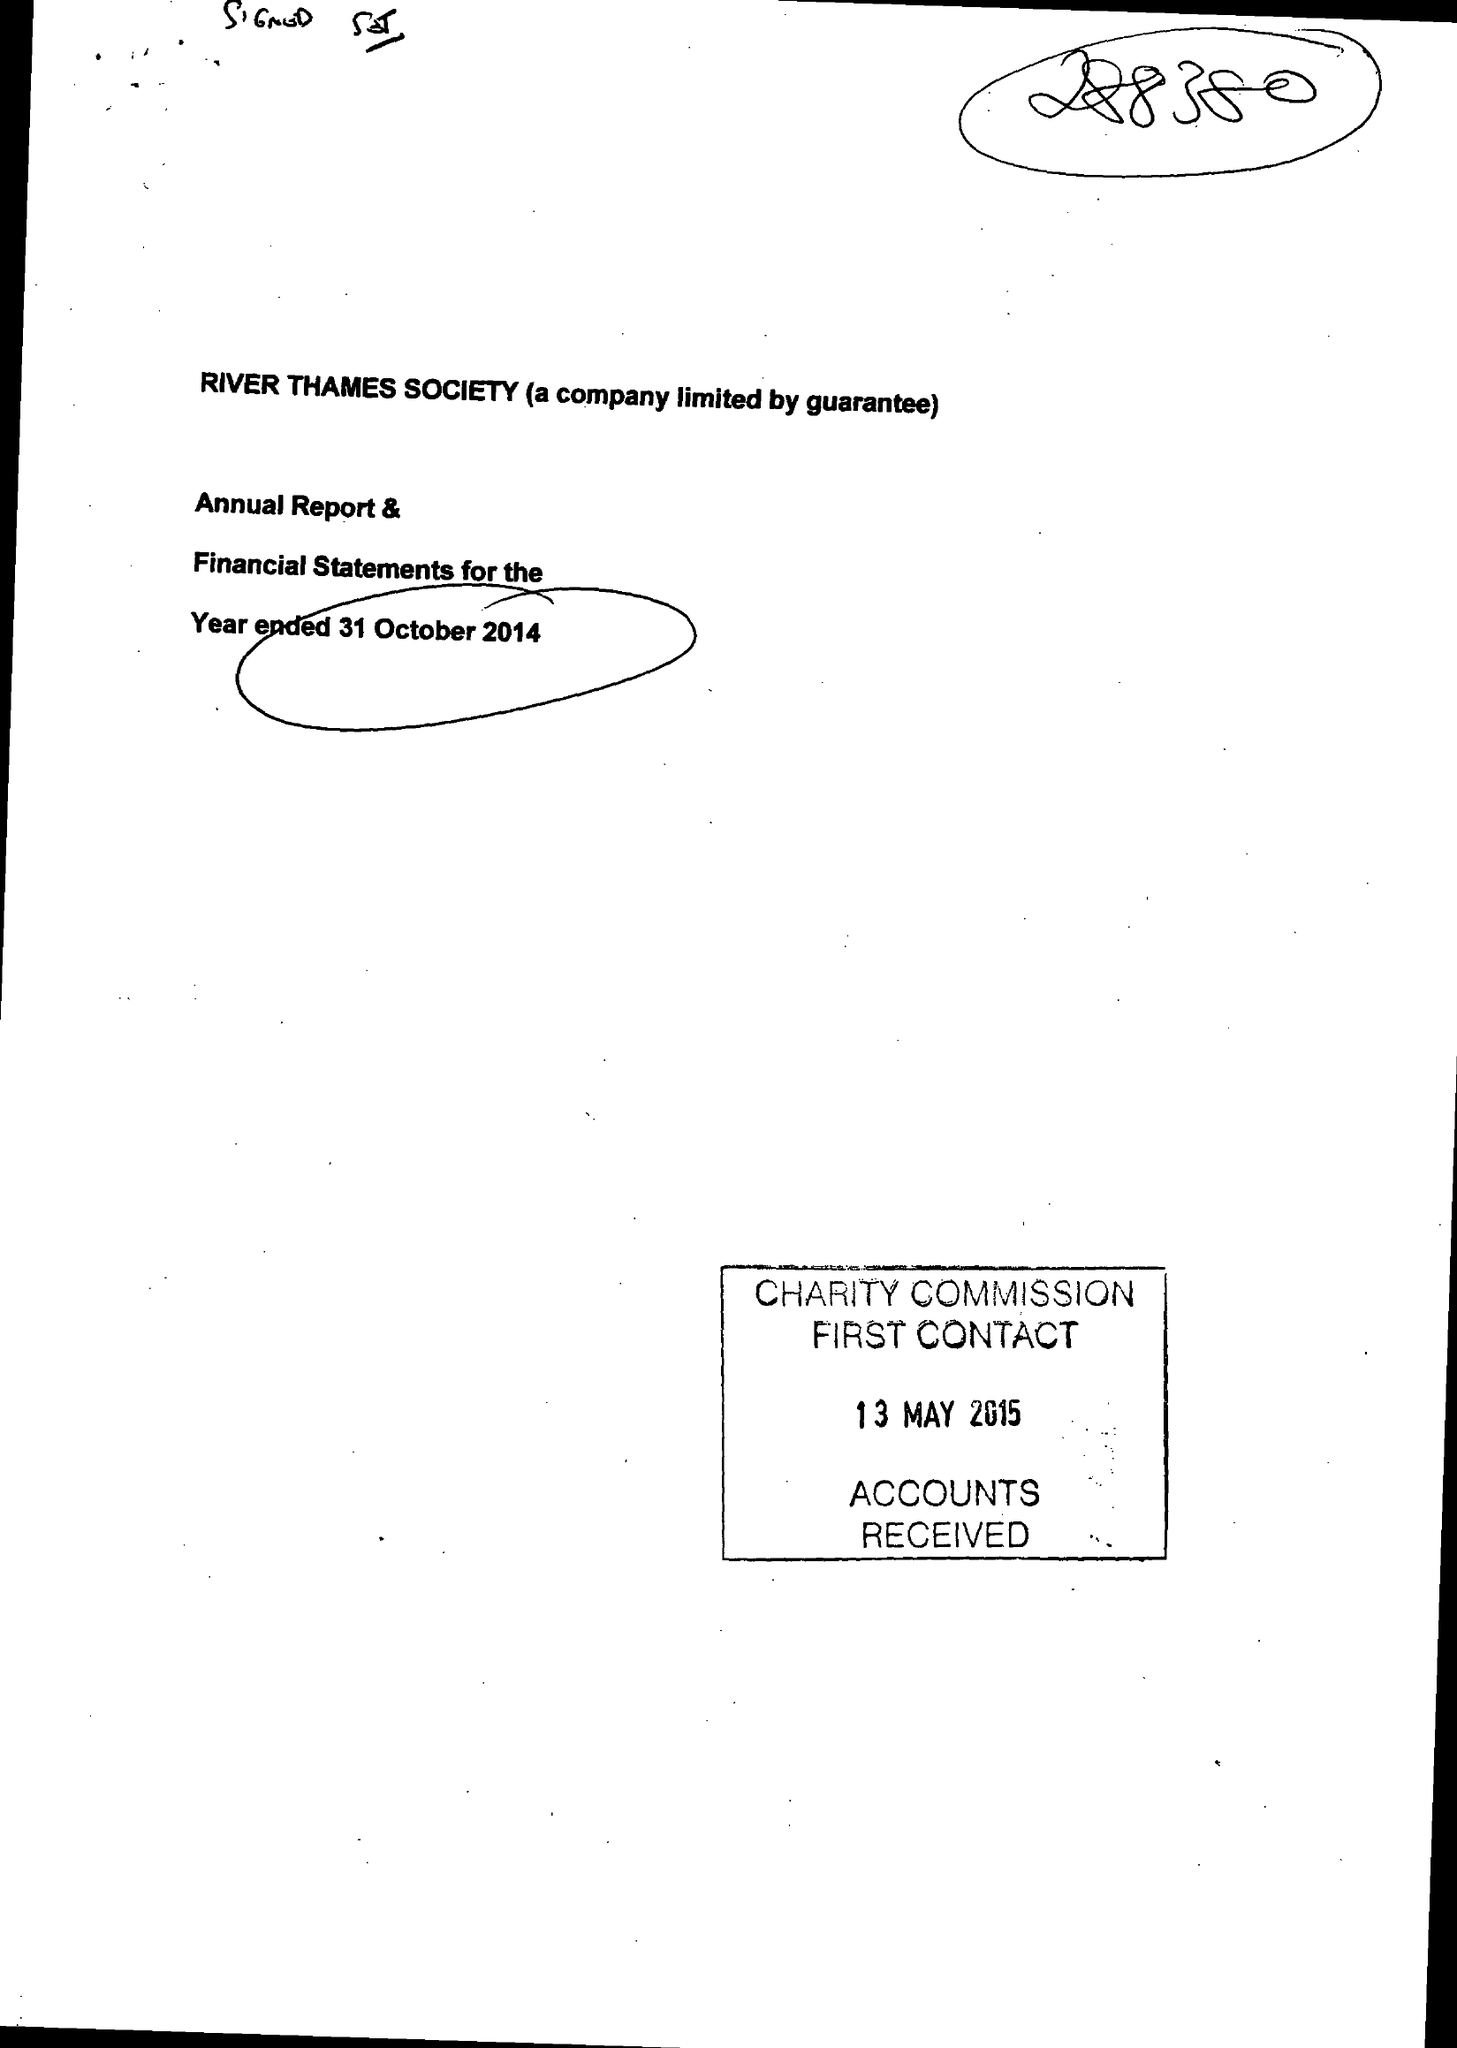What is the value for the report_date?
Answer the question using a single word or phrase. 2014-10-31 